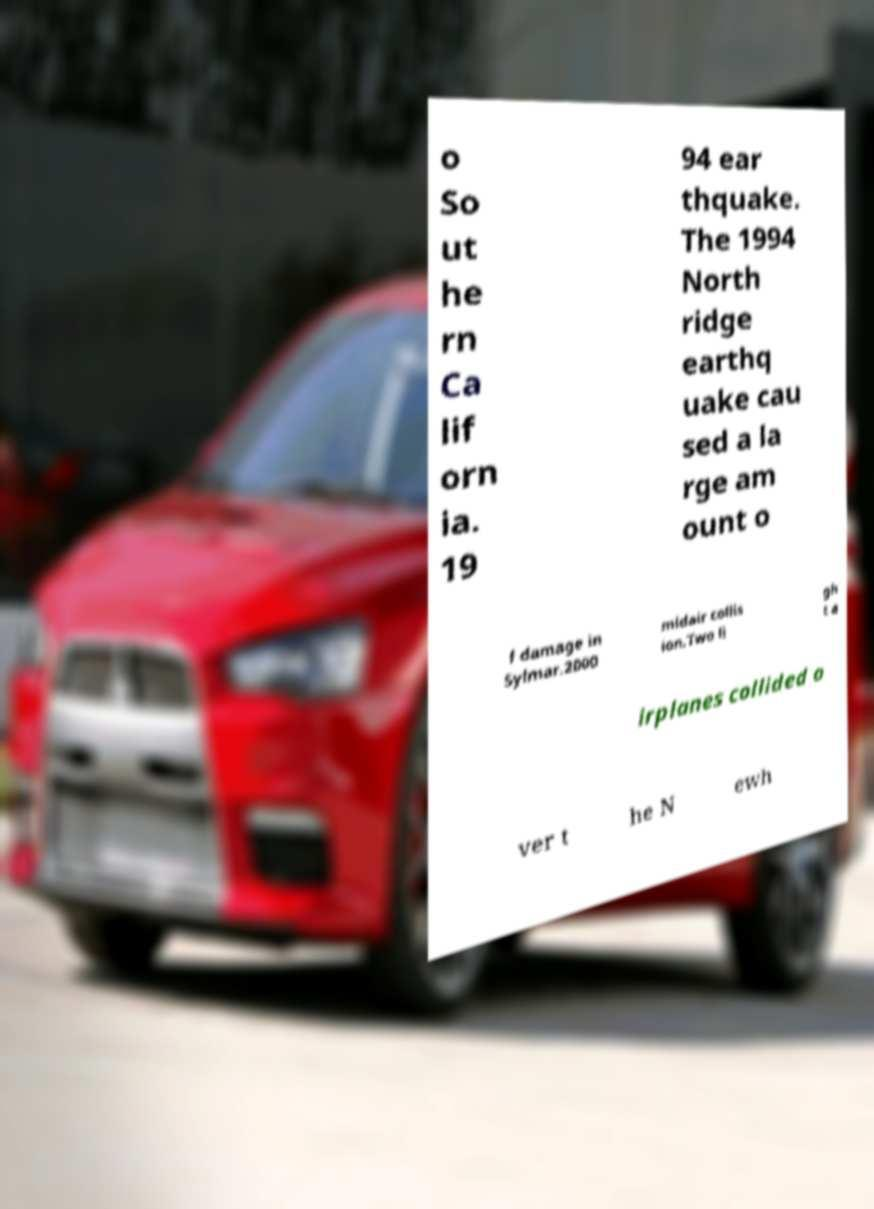Could you assist in decoding the text presented in this image and type it out clearly? o So ut he rn Ca lif orn ia. 19 94 ear thquake. The 1994 North ridge earthq uake cau sed a la rge am ount o f damage in Sylmar.2000 midair collis ion.Two li gh t a irplanes collided o ver t he N ewh 